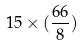<formula> <loc_0><loc_0><loc_500><loc_500>1 5 \times ( \frac { 6 6 } { 8 } )</formula> 